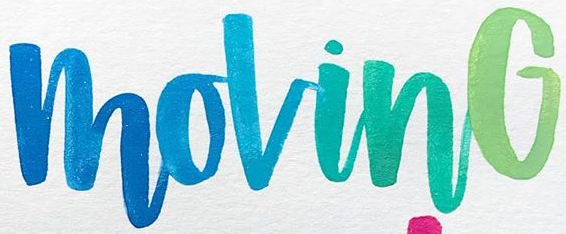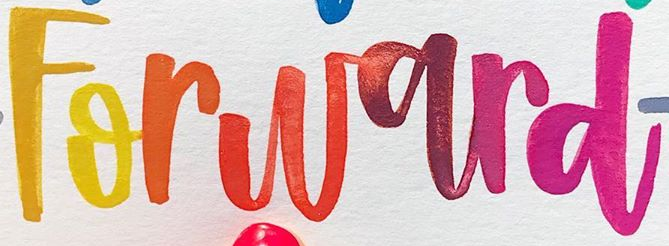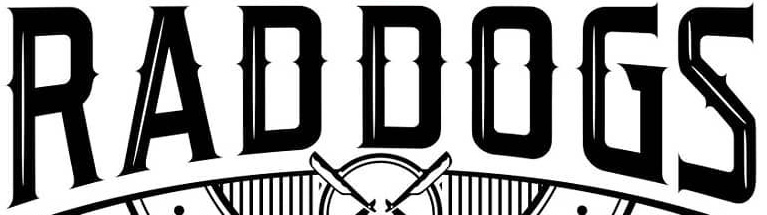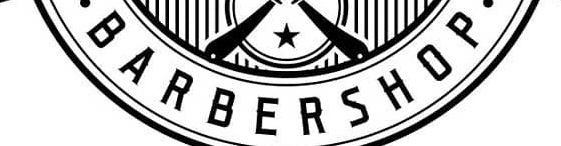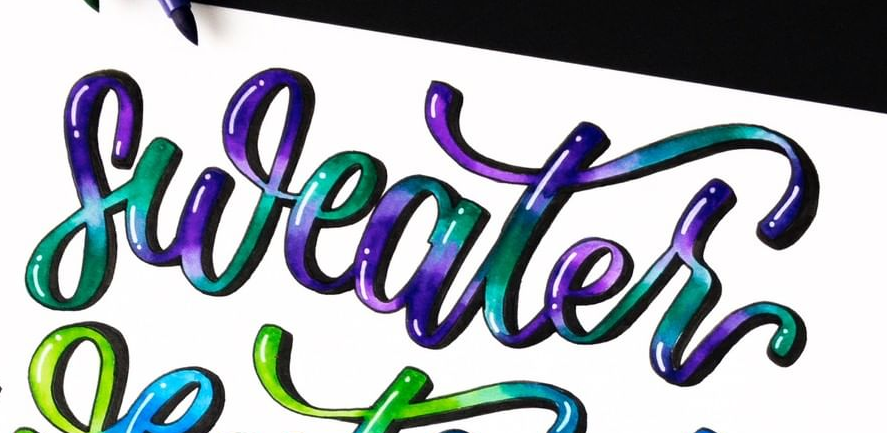What words can you see in these images in sequence, separated by a semicolon? MovinG; Forward; RADDOGS; BARBERSHOP; sweater 